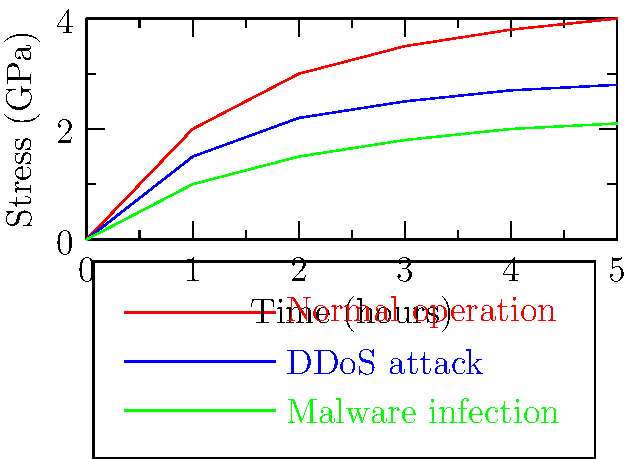Based on the graph showing mechanical stress distribution in a turbine blade under different cyber attack scenarios, which attack type results in the highest stress on the blade over time, and what could be the potential consequences for the power plant's infrastructure? To answer this question, we need to analyze the graph and understand its implications:

1. The graph shows three scenarios: normal operation (red), DDoS attack (blue), and malware infection (green).

2. Stress levels over time:
   - Normal operation: Starts at 0 GPa and increases to 4 GPa after 5 hours.
   - DDoS attack: Starts at 0 GPa and increases to 2.8 GPa after 5 hours.
   - Malware infection: Starts at 0 GPa and increases to 2.1 GPa after 5 hours.

3. Comparing the three scenarios, we can see that normal operation results in the highest stress on the turbine blade over time.

4. This counterintuitive result suggests that the cyber attacks may be targeting the control systems rather than directly affecting the turbine's operation.

5. Potential consequences for the power plant's infrastructure:
   - Increased wear and tear on turbine blades during normal operation.
   - Possible sudden stress changes during attacks, which could lead to fatigue or failure.
   - Unpredictable behavior of control systems during cyber attacks, potentially causing damage to other components.
   - Risk of sudden power output fluctuations, affecting the stability of the electrical grid.

6. The lower stress levels during attacks might indicate that the attackers are attempting to reduce power output or efficiency rather than cause immediate physical damage.
Answer: Normal operation causes highest stress; potential consequences include accelerated wear, system instability, and grid fluctuations. 